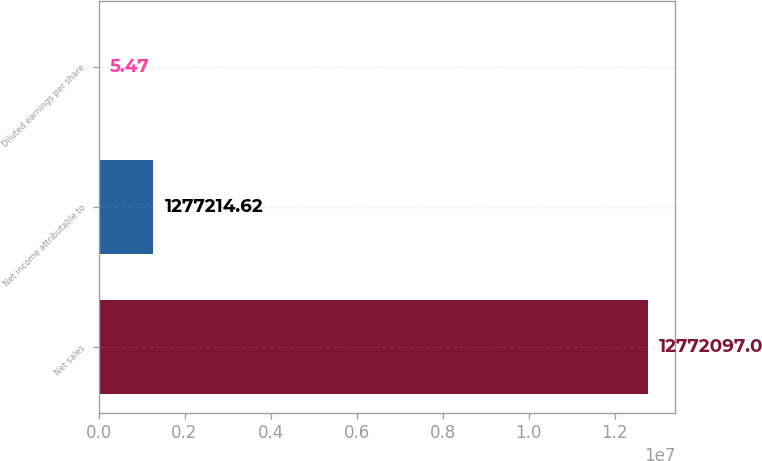<chart> <loc_0><loc_0><loc_500><loc_500><bar_chart><fcel>Net sales<fcel>Net income attributable to<fcel>Diluted earnings per share<nl><fcel>1.27721e+07<fcel>1.27721e+06<fcel>5.47<nl></chart> 